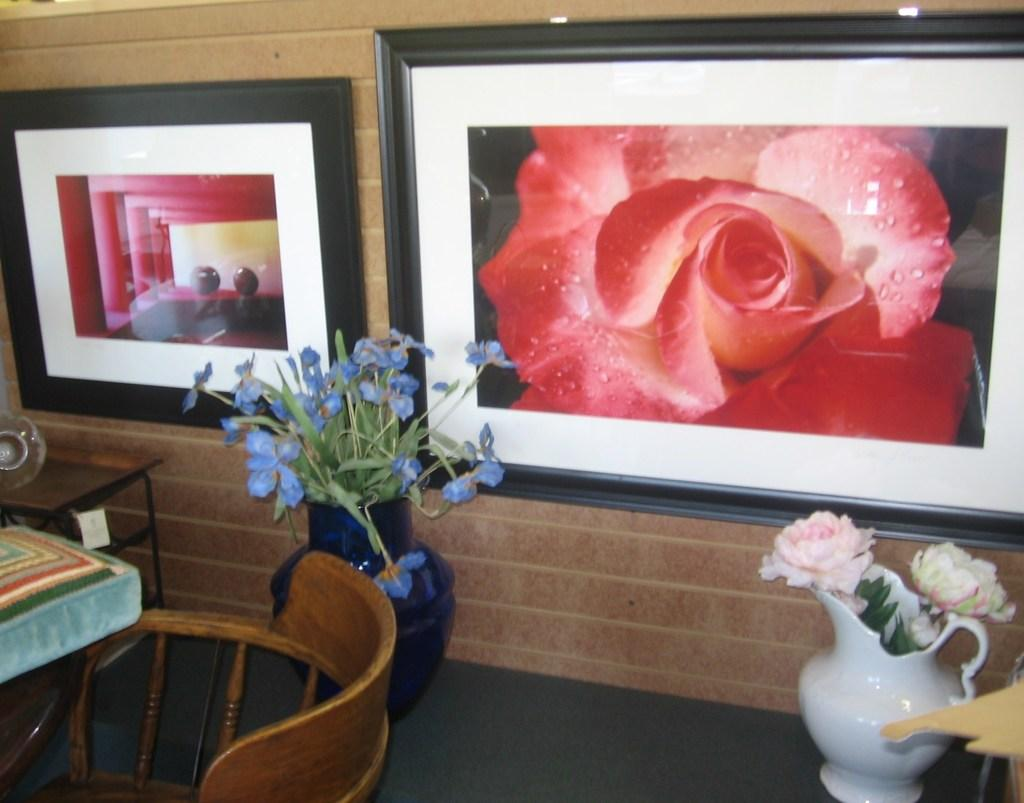How many photo frames are on the wall in the image? There are two photo frames on the wall in the image. What else can be seen in the image besides the photo frames? There are two flower pots and a chair in the image. What type of ear is visible on the chair in the image? There is no ear visible on the chair in the image. Is there a mask covering the flower pots in the image? There is no mask present in the image. 